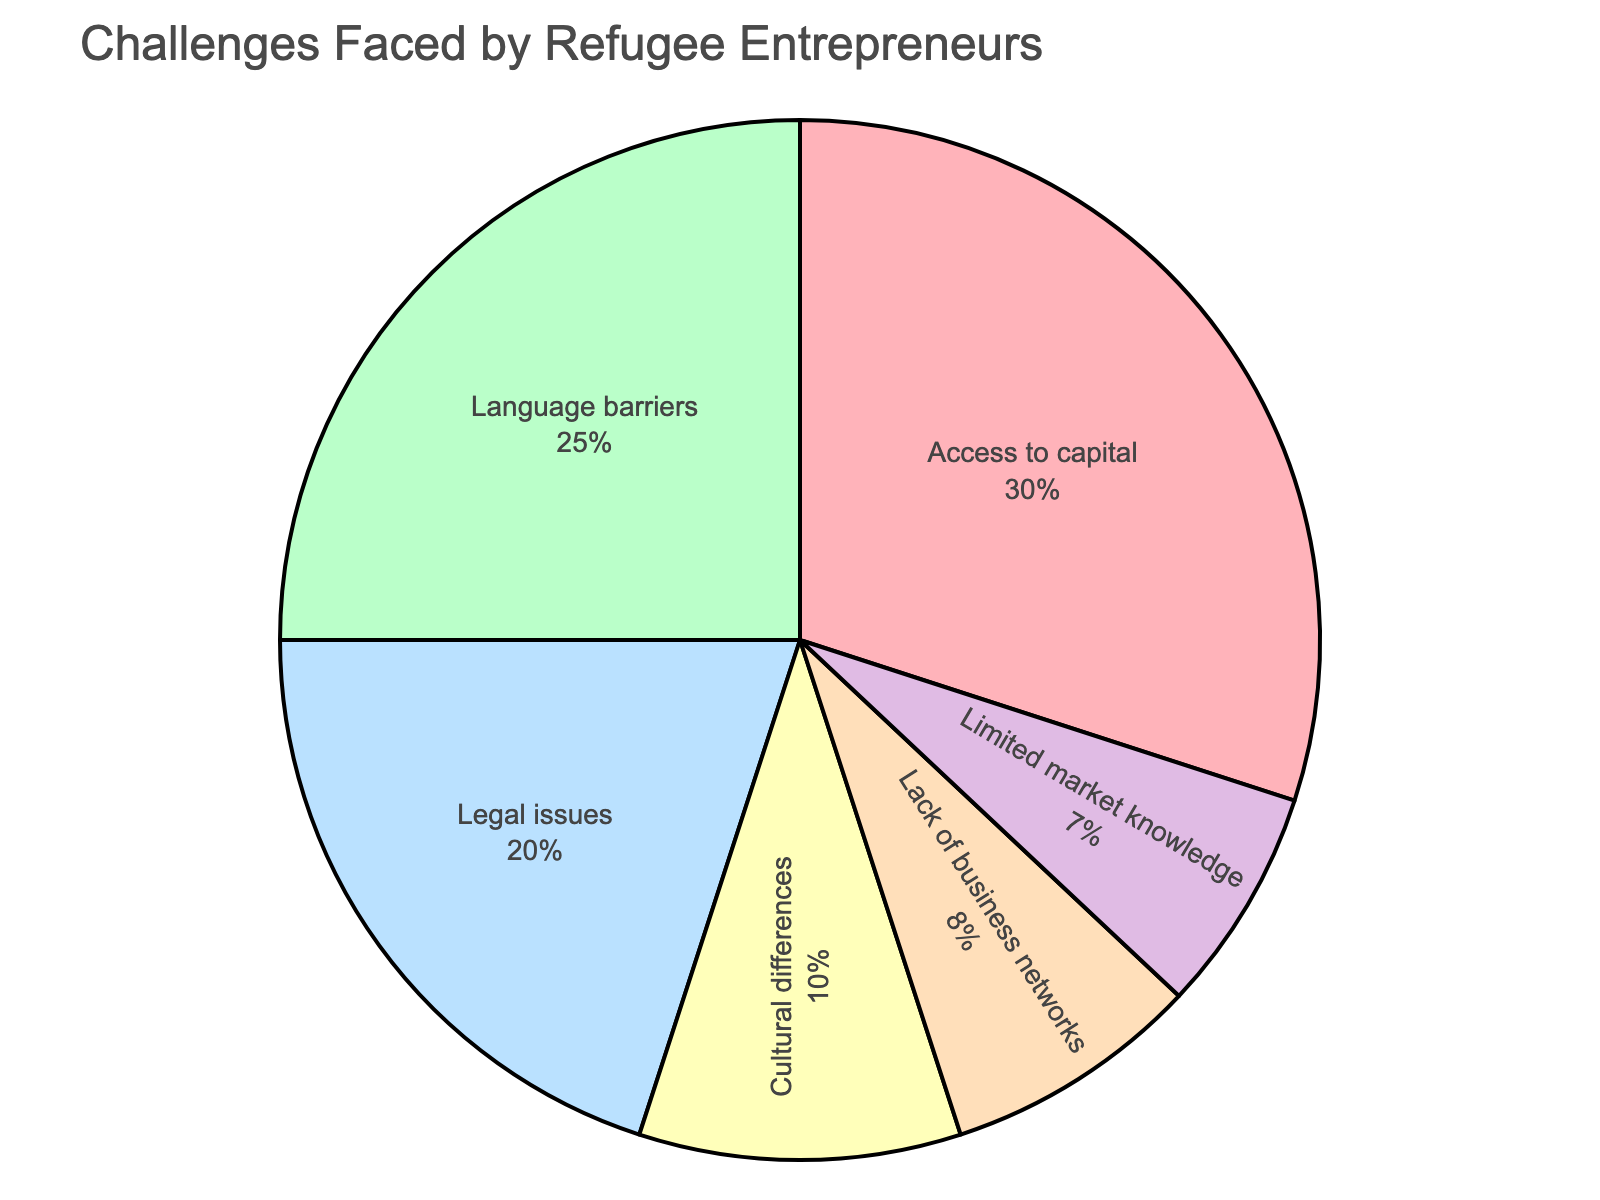What percentage of refugee entrepreneurs face language barriers? Language barriers are shown in a segment which is labeled with its percentage. The figure shows that the percentage for language barriers is 25%.
Answer: 25% Which challenge is faced by the largest percentage of refugee entrepreneurs? By visually comparing the segments of the pie chart, the largest segment corresponds to "Access to capital," which is labeled with 30%.
Answer: Access to capital What is the combined percentage of refugee entrepreneurs facing legal issues and cultural differences? The segment labeled "Legal issues" represents 20%, and the segment labeled "Cultural differences" represents 10%. Adding these two percentages together gives 20% + 10% = 30%.
Answer: 30% How many challenges accounted for less than 10% each for refugee entrepreneurs? Identifying the segments representing less than 10%: "Lack of business networks" (8%) and "Limited market knowledge" (7%). There are two such challenges.
Answer: 2 Is the percentage of refugee entrepreneurs facing language barriers greater than those facing lack of business networks and limited market knowledge combined? The segments for "Language barriers" (25%), "Lack of business networks" (8%), and "Limited market knowledge" (7%) are compared. Adding "Lack of business networks" and "Limited market knowledge" gives 8% + 7% = 15%, which is less than 25%.
Answer: Yes Which color represents legal issues? By looking at the segments with their associated colors, "Legal issues" is represented by a segment in blue.
Answer: Blue Explain how to determine which challenge had the smallest representation percentage-wise. By visually comparing all the segments, the smallest segment corresponds to "Limited market knowledge," which is labeled with 7%. This is the lowest percentage among all segments in the pie chart.
Answer: Limited market knowledge If you were to combine the percentages of language barriers, access to capital, and lack of business networks, what would be the total? Summing the percentages for "Language barriers" (25%), "Access to capital" (30%), and "Lack of business networks" (8%) gives 25% + 30% + 8% = 63%.
Answer: 63% Which color represents the challenge faced by the second-largest percentage of refugee entrepreneurs? The second-largest segment corresponds to "Language barriers," which is labeled 25%. This segment is colored red.
Answer: Red Are there more refugee entrepreneurs dealing with cultural differences or legal issues? By comparing the sizes of the segments, "Legal issues" (20%) is greater than "Cultural differences" (10%).
Answer: Legal issues 